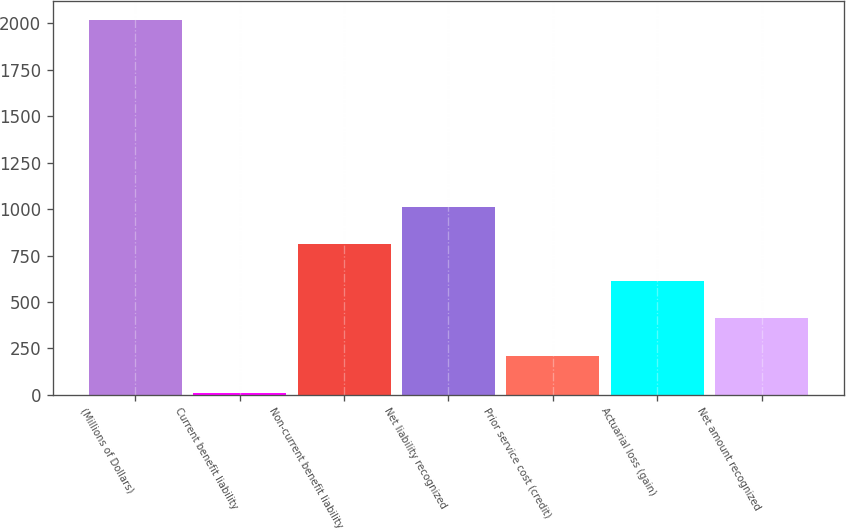Convert chart. <chart><loc_0><loc_0><loc_500><loc_500><bar_chart><fcel>(Millions of Dollars)<fcel>Current benefit liability<fcel>Non-current benefit liability<fcel>Net liability recognized<fcel>Prior service cost (credit)<fcel>Actuarial loss (gain)<fcel>Net amount recognized<nl><fcel>2018<fcel>9.1<fcel>812.66<fcel>1013.55<fcel>209.99<fcel>611.77<fcel>410.88<nl></chart> 